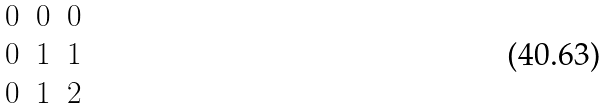Convert formula to latex. <formula><loc_0><loc_0><loc_500><loc_500>\begin{matrix} 0 & 0 & 0 \\ 0 & 1 & 1 \\ 0 & 1 & 2 \end{matrix}</formula> 